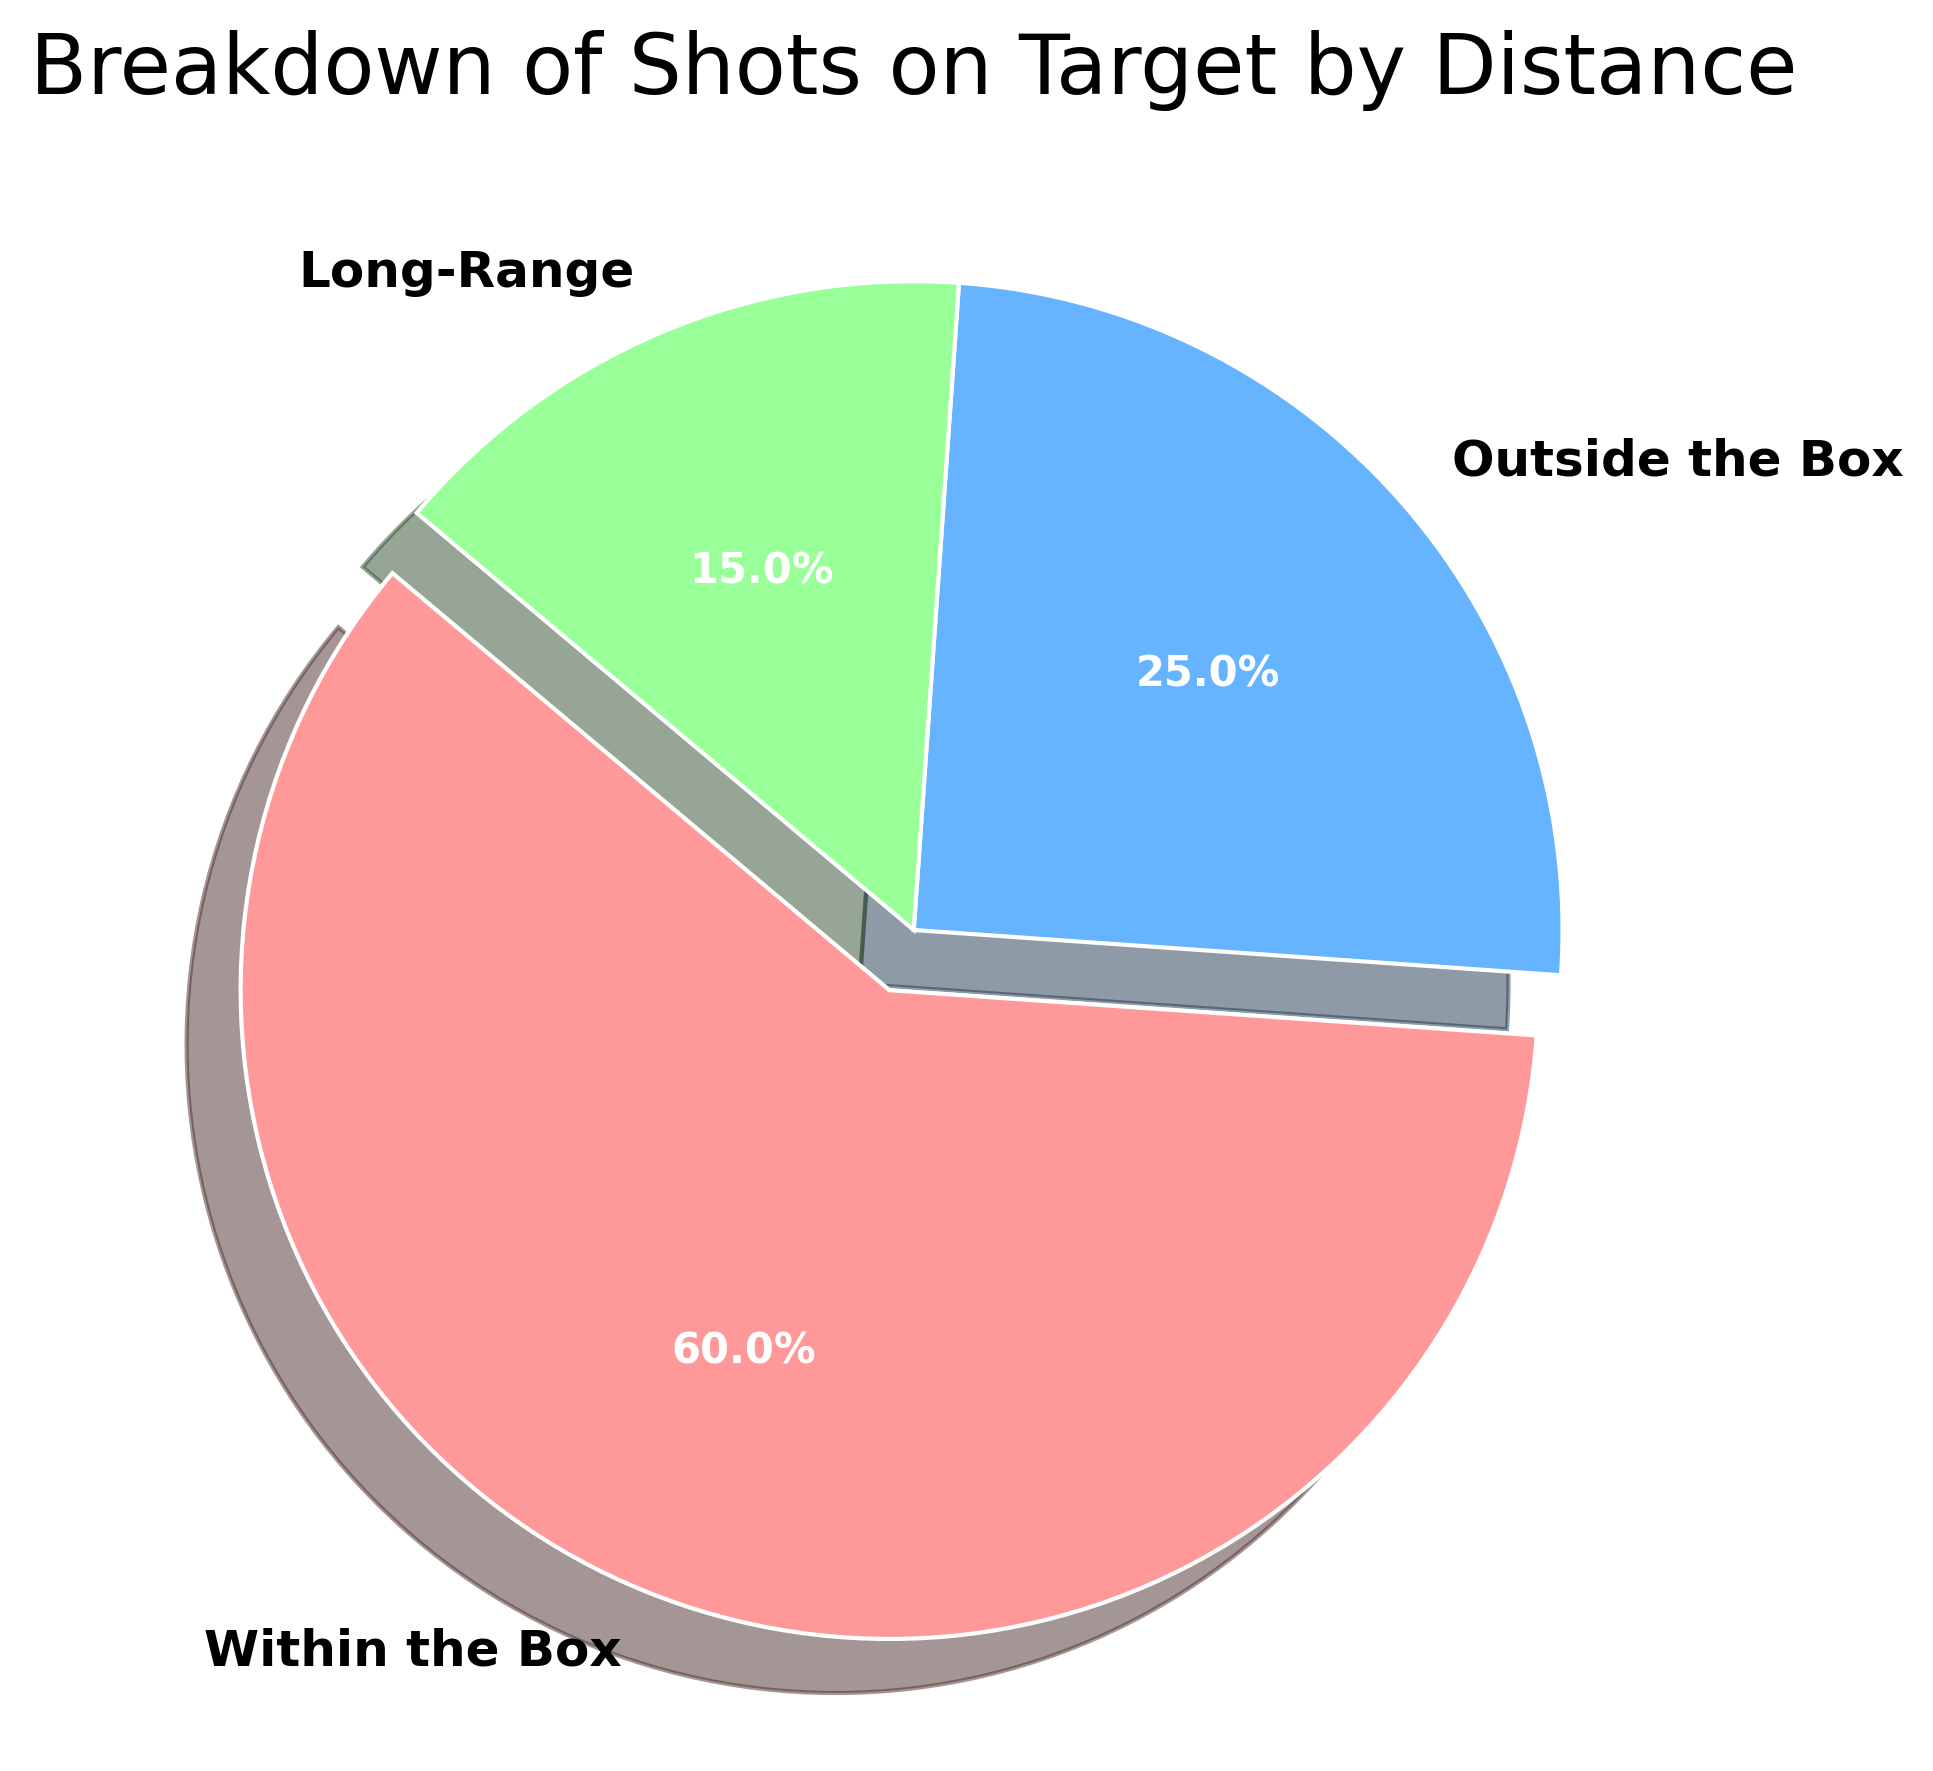What's the percentage of shots taken from within the box? In the pie chart, the percentage of shots taken from within the box is displayed directly. It’s marked as 60% of the total shots.
Answer: 60% Which distance category has the least number of shots? Observing the pie chart, the ‘Long-Range’ section appears the smallest, indicating it has the least percentage of shots, which is 15%.
Answer: Long-Range What is the approximate ratio of shots taken from within the box to shots taken from long-range? The pie chart shows that shots from within the box represent 60% and long-range shots represent 15%. The ratio is 60:15, which simplifies to 4:1.
Answer: 4:1 Compare the shots taken from outside the box and long-range; which is greater and by how much? Outside the box shots are 25% and long-range shots are 15%. The difference is 25% - 15% = 10%. So, shots from outside the box are greater by 10%.
Answer: Outside the box, 10% What is the combined percentage of shots taken from outside the box and long-range? According to the pie chart, outside the box shots are 25%, and long-range shots are 15%. Adding them gives 25% + 15% = 40%.
Answer: 40% What's the main color of the wedge indicating within the box shots? The pie chart shows ‘Within the Box’ section with the largest wedge colored in red.
Answer: Red Looking at the pie chart, what percentage more are 'Within the Box' shots compared to 'Outside the Box' shots? ‘Within the Box’ shots have 60% while ‘Outside the Box’ shots have 25%. 60% - 25% = 35% more.
Answer: 35% more Which shot distance has twice the number compared to long-range shots, and what's the percentage? Identifying from the smallest section, long-range shots (15%), the category with twice the shots would be 15% × 2 = 30%, but outside the box shots (25%) and within the box shots (60%) are higher. Therefore, none exactly at 30%, closest is outside the box but not exactly twice.
Answer: None How do the shots from outside the box and within the box compare in terms of visualization? The 'Within the Box' section is exploded (slightly separated) and distinctly larger, while 'Outside the Box' records a moderately sized wedge. The stark difference in size visually signifies higher shots within the box.
Answer: Exploded, larger If 100 shots are taken, how many would be from long-range and outside the box combined? Combined percentage of long-range (15%) and outside the box (25%) is 40%. For 100 shots, 40% of 100 is 40 shots.
Answer: 40 